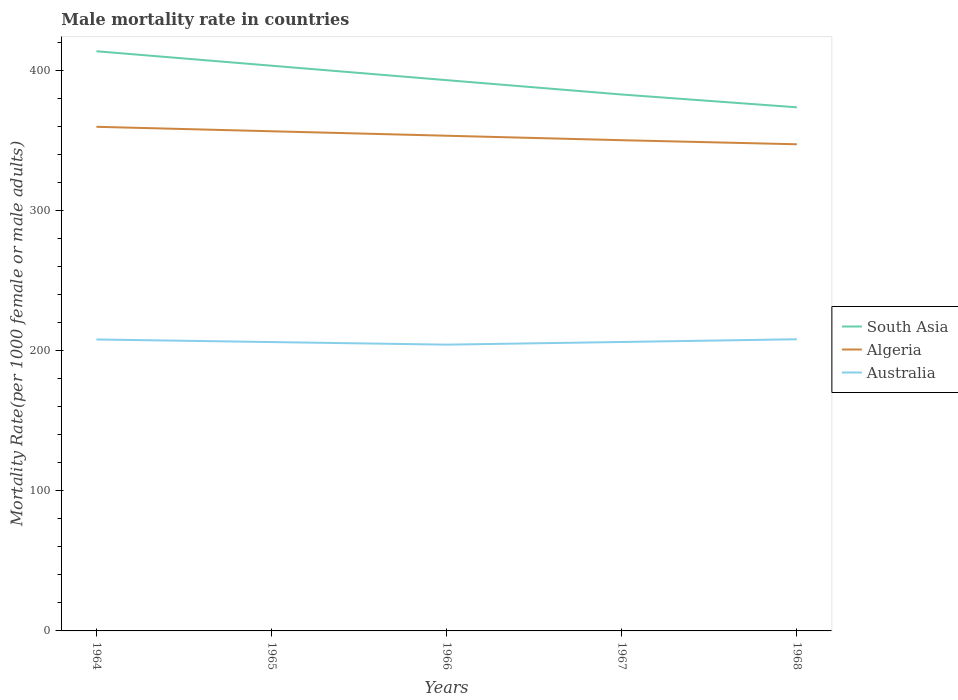Is the number of lines equal to the number of legend labels?
Your answer should be very brief. Yes. Across all years, what is the maximum male mortality rate in South Asia?
Your answer should be compact. 373.93. In which year was the male mortality rate in South Asia maximum?
Keep it short and to the point. 1968. What is the total male mortality rate in South Asia in the graph?
Your answer should be very brief. 9.14. What is the difference between the highest and the second highest male mortality rate in South Asia?
Your answer should be compact. 40.03. What is the difference between the highest and the lowest male mortality rate in South Asia?
Give a very brief answer. 2. Is the male mortality rate in Australia strictly greater than the male mortality rate in Algeria over the years?
Offer a terse response. Yes. Are the values on the major ticks of Y-axis written in scientific E-notation?
Offer a terse response. No. How many legend labels are there?
Your response must be concise. 3. What is the title of the graph?
Offer a very short reply. Male mortality rate in countries. Does "Indonesia" appear as one of the legend labels in the graph?
Keep it short and to the point. No. What is the label or title of the Y-axis?
Keep it short and to the point. Mortality Rate(per 1000 female or male adults). What is the Mortality Rate(per 1000 female or male adults) in South Asia in 1964?
Your answer should be very brief. 413.96. What is the Mortality Rate(per 1000 female or male adults) of Algeria in 1964?
Offer a terse response. 360.01. What is the Mortality Rate(per 1000 female or male adults) in Australia in 1964?
Provide a succinct answer. 208.13. What is the Mortality Rate(per 1000 female or male adults) of South Asia in 1965?
Make the answer very short. 403.64. What is the Mortality Rate(per 1000 female or male adults) in Algeria in 1965?
Ensure brevity in your answer.  356.82. What is the Mortality Rate(per 1000 female or male adults) in Australia in 1965?
Your response must be concise. 206.29. What is the Mortality Rate(per 1000 female or male adults) in South Asia in 1966?
Keep it short and to the point. 393.32. What is the Mortality Rate(per 1000 female or male adults) of Algeria in 1966?
Your answer should be very brief. 353.63. What is the Mortality Rate(per 1000 female or male adults) in Australia in 1966?
Offer a very short reply. 204.44. What is the Mortality Rate(per 1000 female or male adults) of South Asia in 1967?
Provide a short and direct response. 383.07. What is the Mortality Rate(per 1000 female or male adults) in Algeria in 1967?
Your answer should be compact. 350.44. What is the Mortality Rate(per 1000 female or male adults) in Australia in 1967?
Make the answer very short. 206.34. What is the Mortality Rate(per 1000 female or male adults) in South Asia in 1968?
Ensure brevity in your answer.  373.93. What is the Mortality Rate(per 1000 female or male adults) of Algeria in 1968?
Offer a very short reply. 347.54. What is the Mortality Rate(per 1000 female or male adults) in Australia in 1968?
Your answer should be compact. 208.28. Across all years, what is the maximum Mortality Rate(per 1000 female or male adults) in South Asia?
Your response must be concise. 413.96. Across all years, what is the maximum Mortality Rate(per 1000 female or male adults) in Algeria?
Your answer should be compact. 360.01. Across all years, what is the maximum Mortality Rate(per 1000 female or male adults) in Australia?
Offer a very short reply. 208.28. Across all years, what is the minimum Mortality Rate(per 1000 female or male adults) in South Asia?
Ensure brevity in your answer.  373.93. Across all years, what is the minimum Mortality Rate(per 1000 female or male adults) in Algeria?
Provide a succinct answer. 347.54. Across all years, what is the minimum Mortality Rate(per 1000 female or male adults) in Australia?
Offer a terse response. 204.44. What is the total Mortality Rate(per 1000 female or male adults) of South Asia in the graph?
Your answer should be very brief. 1967.92. What is the total Mortality Rate(per 1000 female or male adults) of Algeria in the graph?
Your response must be concise. 1768.42. What is the total Mortality Rate(per 1000 female or male adults) of Australia in the graph?
Keep it short and to the point. 1033.46. What is the difference between the Mortality Rate(per 1000 female or male adults) of South Asia in 1964 and that in 1965?
Ensure brevity in your answer.  10.32. What is the difference between the Mortality Rate(per 1000 female or male adults) of Algeria in 1964 and that in 1965?
Your answer should be very brief. 3.19. What is the difference between the Mortality Rate(per 1000 female or male adults) in Australia in 1964 and that in 1965?
Your answer should be compact. 1.84. What is the difference between the Mortality Rate(per 1000 female or male adults) of South Asia in 1964 and that in 1966?
Keep it short and to the point. 20.64. What is the difference between the Mortality Rate(per 1000 female or male adults) in Algeria in 1964 and that in 1966?
Offer a terse response. 6.38. What is the difference between the Mortality Rate(per 1000 female or male adults) of Australia in 1964 and that in 1966?
Offer a terse response. 3.69. What is the difference between the Mortality Rate(per 1000 female or male adults) in South Asia in 1964 and that in 1967?
Offer a terse response. 30.89. What is the difference between the Mortality Rate(per 1000 female or male adults) of Algeria in 1964 and that in 1967?
Give a very brief answer. 9.57. What is the difference between the Mortality Rate(per 1000 female or male adults) of Australia in 1964 and that in 1967?
Your answer should be very brief. 1.79. What is the difference between the Mortality Rate(per 1000 female or male adults) of South Asia in 1964 and that in 1968?
Offer a very short reply. 40.03. What is the difference between the Mortality Rate(per 1000 female or male adults) of Algeria in 1964 and that in 1968?
Give a very brief answer. 12.47. What is the difference between the Mortality Rate(per 1000 female or male adults) of Australia in 1964 and that in 1968?
Ensure brevity in your answer.  -0.15. What is the difference between the Mortality Rate(per 1000 female or male adults) of South Asia in 1965 and that in 1966?
Keep it short and to the point. 10.32. What is the difference between the Mortality Rate(per 1000 female or male adults) in Algeria in 1965 and that in 1966?
Your answer should be very brief. 3.19. What is the difference between the Mortality Rate(per 1000 female or male adults) of Australia in 1965 and that in 1966?
Make the answer very short. 1.85. What is the difference between the Mortality Rate(per 1000 female or male adults) in South Asia in 1965 and that in 1967?
Give a very brief answer. 20.57. What is the difference between the Mortality Rate(per 1000 female or male adults) of Algeria in 1965 and that in 1967?
Provide a short and direct response. 6.38. What is the difference between the Mortality Rate(per 1000 female or male adults) of Australia in 1965 and that in 1967?
Offer a terse response. -0.05. What is the difference between the Mortality Rate(per 1000 female or male adults) in South Asia in 1965 and that in 1968?
Ensure brevity in your answer.  29.71. What is the difference between the Mortality Rate(per 1000 female or male adults) of Algeria in 1965 and that in 1968?
Provide a short and direct response. 9.28. What is the difference between the Mortality Rate(per 1000 female or male adults) of Australia in 1965 and that in 1968?
Offer a very short reply. -1.99. What is the difference between the Mortality Rate(per 1000 female or male adults) in South Asia in 1966 and that in 1967?
Provide a succinct answer. 10.25. What is the difference between the Mortality Rate(per 1000 female or male adults) of Algeria in 1966 and that in 1967?
Make the answer very short. 3.19. What is the difference between the Mortality Rate(per 1000 female or male adults) in Australia in 1966 and that in 1967?
Make the answer very short. -1.9. What is the difference between the Mortality Rate(per 1000 female or male adults) of South Asia in 1966 and that in 1968?
Provide a succinct answer. 19.39. What is the difference between the Mortality Rate(per 1000 female or male adults) in Algeria in 1966 and that in 1968?
Keep it short and to the point. 6.09. What is the difference between the Mortality Rate(per 1000 female or male adults) of Australia in 1966 and that in 1968?
Keep it short and to the point. -3.84. What is the difference between the Mortality Rate(per 1000 female or male adults) of South Asia in 1967 and that in 1968?
Your answer should be very brief. 9.14. What is the difference between the Mortality Rate(per 1000 female or male adults) of Algeria in 1967 and that in 1968?
Give a very brief answer. 2.9. What is the difference between the Mortality Rate(per 1000 female or male adults) in Australia in 1967 and that in 1968?
Your answer should be compact. -1.94. What is the difference between the Mortality Rate(per 1000 female or male adults) in South Asia in 1964 and the Mortality Rate(per 1000 female or male adults) in Algeria in 1965?
Your answer should be compact. 57.15. What is the difference between the Mortality Rate(per 1000 female or male adults) in South Asia in 1964 and the Mortality Rate(per 1000 female or male adults) in Australia in 1965?
Make the answer very short. 207.68. What is the difference between the Mortality Rate(per 1000 female or male adults) in Algeria in 1964 and the Mortality Rate(per 1000 female or male adults) in Australia in 1965?
Make the answer very short. 153.72. What is the difference between the Mortality Rate(per 1000 female or male adults) of South Asia in 1964 and the Mortality Rate(per 1000 female or male adults) of Algeria in 1966?
Give a very brief answer. 60.34. What is the difference between the Mortality Rate(per 1000 female or male adults) of South Asia in 1964 and the Mortality Rate(per 1000 female or male adults) of Australia in 1966?
Make the answer very short. 209.53. What is the difference between the Mortality Rate(per 1000 female or male adults) of Algeria in 1964 and the Mortality Rate(per 1000 female or male adults) of Australia in 1966?
Your answer should be compact. 155.57. What is the difference between the Mortality Rate(per 1000 female or male adults) in South Asia in 1964 and the Mortality Rate(per 1000 female or male adults) in Algeria in 1967?
Provide a succinct answer. 63.53. What is the difference between the Mortality Rate(per 1000 female or male adults) of South Asia in 1964 and the Mortality Rate(per 1000 female or male adults) of Australia in 1967?
Your answer should be compact. 207.63. What is the difference between the Mortality Rate(per 1000 female or male adults) in Algeria in 1964 and the Mortality Rate(per 1000 female or male adults) in Australia in 1967?
Make the answer very short. 153.67. What is the difference between the Mortality Rate(per 1000 female or male adults) in South Asia in 1964 and the Mortality Rate(per 1000 female or male adults) in Algeria in 1968?
Keep it short and to the point. 66.43. What is the difference between the Mortality Rate(per 1000 female or male adults) in South Asia in 1964 and the Mortality Rate(per 1000 female or male adults) in Australia in 1968?
Offer a very short reply. 205.69. What is the difference between the Mortality Rate(per 1000 female or male adults) in Algeria in 1964 and the Mortality Rate(per 1000 female or male adults) in Australia in 1968?
Your answer should be very brief. 151.73. What is the difference between the Mortality Rate(per 1000 female or male adults) of South Asia in 1965 and the Mortality Rate(per 1000 female or male adults) of Algeria in 1966?
Your answer should be compact. 50.01. What is the difference between the Mortality Rate(per 1000 female or male adults) of South Asia in 1965 and the Mortality Rate(per 1000 female or male adults) of Australia in 1966?
Keep it short and to the point. 199.2. What is the difference between the Mortality Rate(per 1000 female or male adults) in Algeria in 1965 and the Mortality Rate(per 1000 female or male adults) in Australia in 1966?
Keep it short and to the point. 152.38. What is the difference between the Mortality Rate(per 1000 female or male adults) in South Asia in 1965 and the Mortality Rate(per 1000 female or male adults) in Algeria in 1967?
Provide a succinct answer. 53.2. What is the difference between the Mortality Rate(per 1000 female or male adults) of South Asia in 1965 and the Mortality Rate(per 1000 female or male adults) of Australia in 1967?
Give a very brief answer. 197.3. What is the difference between the Mortality Rate(per 1000 female or male adults) of Algeria in 1965 and the Mortality Rate(per 1000 female or male adults) of Australia in 1967?
Keep it short and to the point. 150.48. What is the difference between the Mortality Rate(per 1000 female or male adults) in South Asia in 1965 and the Mortality Rate(per 1000 female or male adults) in Algeria in 1968?
Your answer should be compact. 56.1. What is the difference between the Mortality Rate(per 1000 female or male adults) of South Asia in 1965 and the Mortality Rate(per 1000 female or male adults) of Australia in 1968?
Keep it short and to the point. 195.36. What is the difference between the Mortality Rate(per 1000 female or male adults) of Algeria in 1965 and the Mortality Rate(per 1000 female or male adults) of Australia in 1968?
Give a very brief answer. 148.54. What is the difference between the Mortality Rate(per 1000 female or male adults) in South Asia in 1966 and the Mortality Rate(per 1000 female or male adults) in Algeria in 1967?
Your answer should be compact. 42.88. What is the difference between the Mortality Rate(per 1000 female or male adults) in South Asia in 1966 and the Mortality Rate(per 1000 female or male adults) in Australia in 1967?
Provide a succinct answer. 186.98. What is the difference between the Mortality Rate(per 1000 female or male adults) of Algeria in 1966 and the Mortality Rate(per 1000 female or male adults) of Australia in 1967?
Offer a very short reply. 147.29. What is the difference between the Mortality Rate(per 1000 female or male adults) of South Asia in 1966 and the Mortality Rate(per 1000 female or male adults) of Algeria in 1968?
Your response must be concise. 45.78. What is the difference between the Mortality Rate(per 1000 female or male adults) in South Asia in 1966 and the Mortality Rate(per 1000 female or male adults) in Australia in 1968?
Offer a very short reply. 185.04. What is the difference between the Mortality Rate(per 1000 female or male adults) in Algeria in 1966 and the Mortality Rate(per 1000 female or male adults) in Australia in 1968?
Your response must be concise. 145.35. What is the difference between the Mortality Rate(per 1000 female or male adults) of South Asia in 1967 and the Mortality Rate(per 1000 female or male adults) of Algeria in 1968?
Provide a short and direct response. 35.53. What is the difference between the Mortality Rate(per 1000 female or male adults) in South Asia in 1967 and the Mortality Rate(per 1000 female or male adults) in Australia in 1968?
Offer a very short reply. 174.79. What is the difference between the Mortality Rate(per 1000 female or male adults) of Algeria in 1967 and the Mortality Rate(per 1000 female or male adults) of Australia in 1968?
Offer a very short reply. 142.16. What is the average Mortality Rate(per 1000 female or male adults) of South Asia per year?
Keep it short and to the point. 393.58. What is the average Mortality Rate(per 1000 female or male adults) of Algeria per year?
Provide a succinct answer. 353.68. What is the average Mortality Rate(per 1000 female or male adults) in Australia per year?
Your answer should be compact. 206.69. In the year 1964, what is the difference between the Mortality Rate(per 1000 female or male adults) of South Asia and Mortality Rate(per 1000 female or male adults) of Algeria?
Keep it short and to the point. 53.96. In the year 1964, what is the difference between the Mortality Rate(per 1000 female or male adults) of South Asia and Mortality Rate(per 1000 female or male adults) of Australia?
Your response must be concise. 205.84. In the year 1964, what is the difference between the Mortality Rate(per 1000 female or male adults) of Algeria and Mortality Rate(per 1000 female or male adults) of Australia?
Offer a terse response. 151.88. In the year 1965, what is the difference between the Mortality Rate(per 1000 female or male adults) of South Asia and Mortality Rate(per 1000 female or male adults) of Algeria?
Your answer should be very brief. 46.82. In the year 1965, what is the difference between the Mortality Rate(per 1000 female or male adults) of South Asia and Mortality Rate(per 1000 female or male adults) of Australia?
Your answer should be compact. 197.35. In the year 1965, what is the difference between the Mortality Rate(per 1000 female or male adults) in Algeria and Mortality Rate(per 1000 female or male adults) in Australia?
Your response must be concise. 150.53. In the year 1966, what is the difference between the Mortality Rate(per 1000 female or male adults) in South Asia and Mortality Rate(per 1000 female or male adults) in Algeria?
Your answer should be compact. 39.69. In the year 1966, what is the difference between the Mortality Rate(per 1000 female or male adults) of South Asia and Mortality Rate(per 1000 female or male adults) of Australia?
Keep it short and to the point. 188.88. In the year 1966, what is the difference between the Mortality Rate(per 1000 female or male adults) in Algeria and Mortality Rate(per 1000 female or male adults) in Australia?
Provide a short and direct response. 149.19. In the year 1967, what is the difference between the Mortality Rate(per 1000 female or male adults) in South Asia and Mortality Rate(per 1000 female or male adults) in Algeria?
Your answer should be very brief. 32.63. In the year 1967, what is the difference between the Mortality Rate(per 1000 female or male adults) in South Asia and Mortality Rate(per 1000 female or male adults) in Australia?
Provide a succinct answer. 176.73. In the year 1967, what is the difference between the Mortality Rate(per 1000 female or male adults) of Algeria and Mortality Rate(per 1000 female or male adults) of Australia?
Offer a very short reply. 144.1. In the year 1968, what is the difference between the Mortality Rate(per 1000 female or male adults) of South Asia and Mortality Rate(per 1000 female or male adults) of Algeria?
Provide a short and direct response. 26.39. In the year 1968, what is the difference between the Mortality Rate(per 1000 female or male adults) of South Asia and Mortality Rate(per 1000 female or male adults) of Australia?
Your answer should be very brief. 165.66. In the year 1968, what is the difference between the Mortality Rate(per 1000 female or male adults) in Algeria and Mortality Rate(per 1000 female or male adults) in Australia?
Your answer should be very brief. 139.26. What is the ratio of the Mortality Rate(per 1000 female or male adults) in South Asia in 1964 to that in 1965?
Keep it short and to the point. 1.03. What is the ratio of the Mortality Rate(per 1000 female or male adults) of Algeria in 1964 to that in 1965?
Ensure brevity in your answer.  1.01. What is the ratio of the Mortality Rate(per 1000 female or male adults) in Australia in 1964 to that in 1965?
Ensure brevity in your answer.  1.01. What is the ratio of the Mortality Rate(per 1000 female or male adults) of South Asia in 1964 to that in 1966?
Your answer should be compact. 1.05. What is the ratio of the Mortality Rate(per 1000 female or male adults) of Algeria in 1964 to that in 1966?
Ensure brevity in your answer.  1.02. What is the ratio of the Mortality Rate(per 1000 female or male adults) of Australia in 1964 to that in 1966?
Make the answer very short. 1.02. What is the ratio of the Mortality Rate(per 1000 female or male adults) of South Asia in 1964 to that in 1967?
Offer a terse response. 1.08. What is the ratio of the Mortality Rate(per 1000 female or male adults) of Algeria in 1964 to that in 1967?
Provide a succinct answer. 1.03. What is the ratio of the Mortality Rate(per 1000 female or male adults) of Australia in 1964 to that in 1967?
Offer a very short reply. 1.01. What is the ratio of the Mortality Rate(per 1000 female or male adults) of South Asia in 1964 to that in 1968?
Provide a succinct answer. 1.11. What is the ratio of the Mortality Rate(per 1000 female or male adults) in Algeria in 1964 to that in 1968?
Ensure brevity in your answer.  1.04. What is the ratio of the Mortality Rate(per 1000 female or male adults) in South Asia in 1965 to that in 1966?
Your response must be concise. 1.03. What is the ratio of the Mortality Rate(per 1000 female or male adults) in Australia in 1965 to that in 1966?
Make the answer very short. 1.01. What is the ratio of the Mortality Rate(per 1000 female or male adults) of South Asia in 1965 to that in 1967?
Your answer should be compact. 1.05. What is the ratio of the Mortality Rate(per 1000 female or male adults) of Algeria in 1965 to that in 1967?
Your answer should be very brief. 1.02. What is the ratio of the Mortality Rate(per 1000 female or male adults) in Australia in 1965 to that in 1967?
Offer a terse response. 1. What is the ratio of the Mortality Rate(per 1000 female or male adults) in South Asia in 1965 to that in 1968?
Provide a short and direct response. 1.08. What is the ratio of the Mortality Rate(per 1000 female or male adults) in Algeria in 1965 to that in 1968?
Keep it short and to the point. 1.03. What is the ratio of the Mortality Rate(per 1000 female or male adults) of South Asia in 1966 to that in 1967?
Give a very brief answer. 1.03. What is the ratio of the Mortality Rate(per 1000 female or male adults) of Algeria in 1966 to that in 1967?
Ensure brevity in your answer.  1.01. What is the ratio of the Mortality Rate(per 1000 female or male adults) in South Asia in 1966 to that in 1968?
Make the answer very short. 1.05. What is the ratio of the Mortality Rate(per 1000 female or male adults) of Algeria in 1966 to that in 1968?
Offer a very short reply. 1.02. What is the ratio of the Mortality Rate(per 1000 female or male adults) of Australia in 1966 to that in 1968?
Provide a short and direct response. 0.98. What is the ratio of the Mortality Rate(per 1000 female or male adults) in South Asia in 1967 to that in 1968?
Give a very brief answer. 1.02. What is the ratio of the Mortality Rate(per 1000 female or male adults) in Algeria in 1967 to that in 1968?
Your answer should be very brief. 1.01. What is the difference between the highest and the second highest Mortality Rate(per 1000 female or male adults) of South Asia?
Your answer should be very brief. 10.32. What is the difference between the highest and the second highest Mortality Rate(per 1000 female or male adults) in Algeria?
Your response must be concise. 3.19. What is the difference between the highest and the second highest Mortality Rate(per 1000 female or male adults) in Australia?
Give a very brief answer. 0.15. What is the difference between the highest and the lowest Mortality Rate(per 1000 female or male adults) in South Asia?
Make the answer very short. 40.03. What is the difference between the highest and the lowest Mortality Rate(per 1000 female or male adults) in Algeria?
Provide a succinct answer. 12.47. What is the difference between the highest and the lowest Mortality Rate(per 1000 female or male adults) of Australia?
Provide a succinct answer. 3.84. 